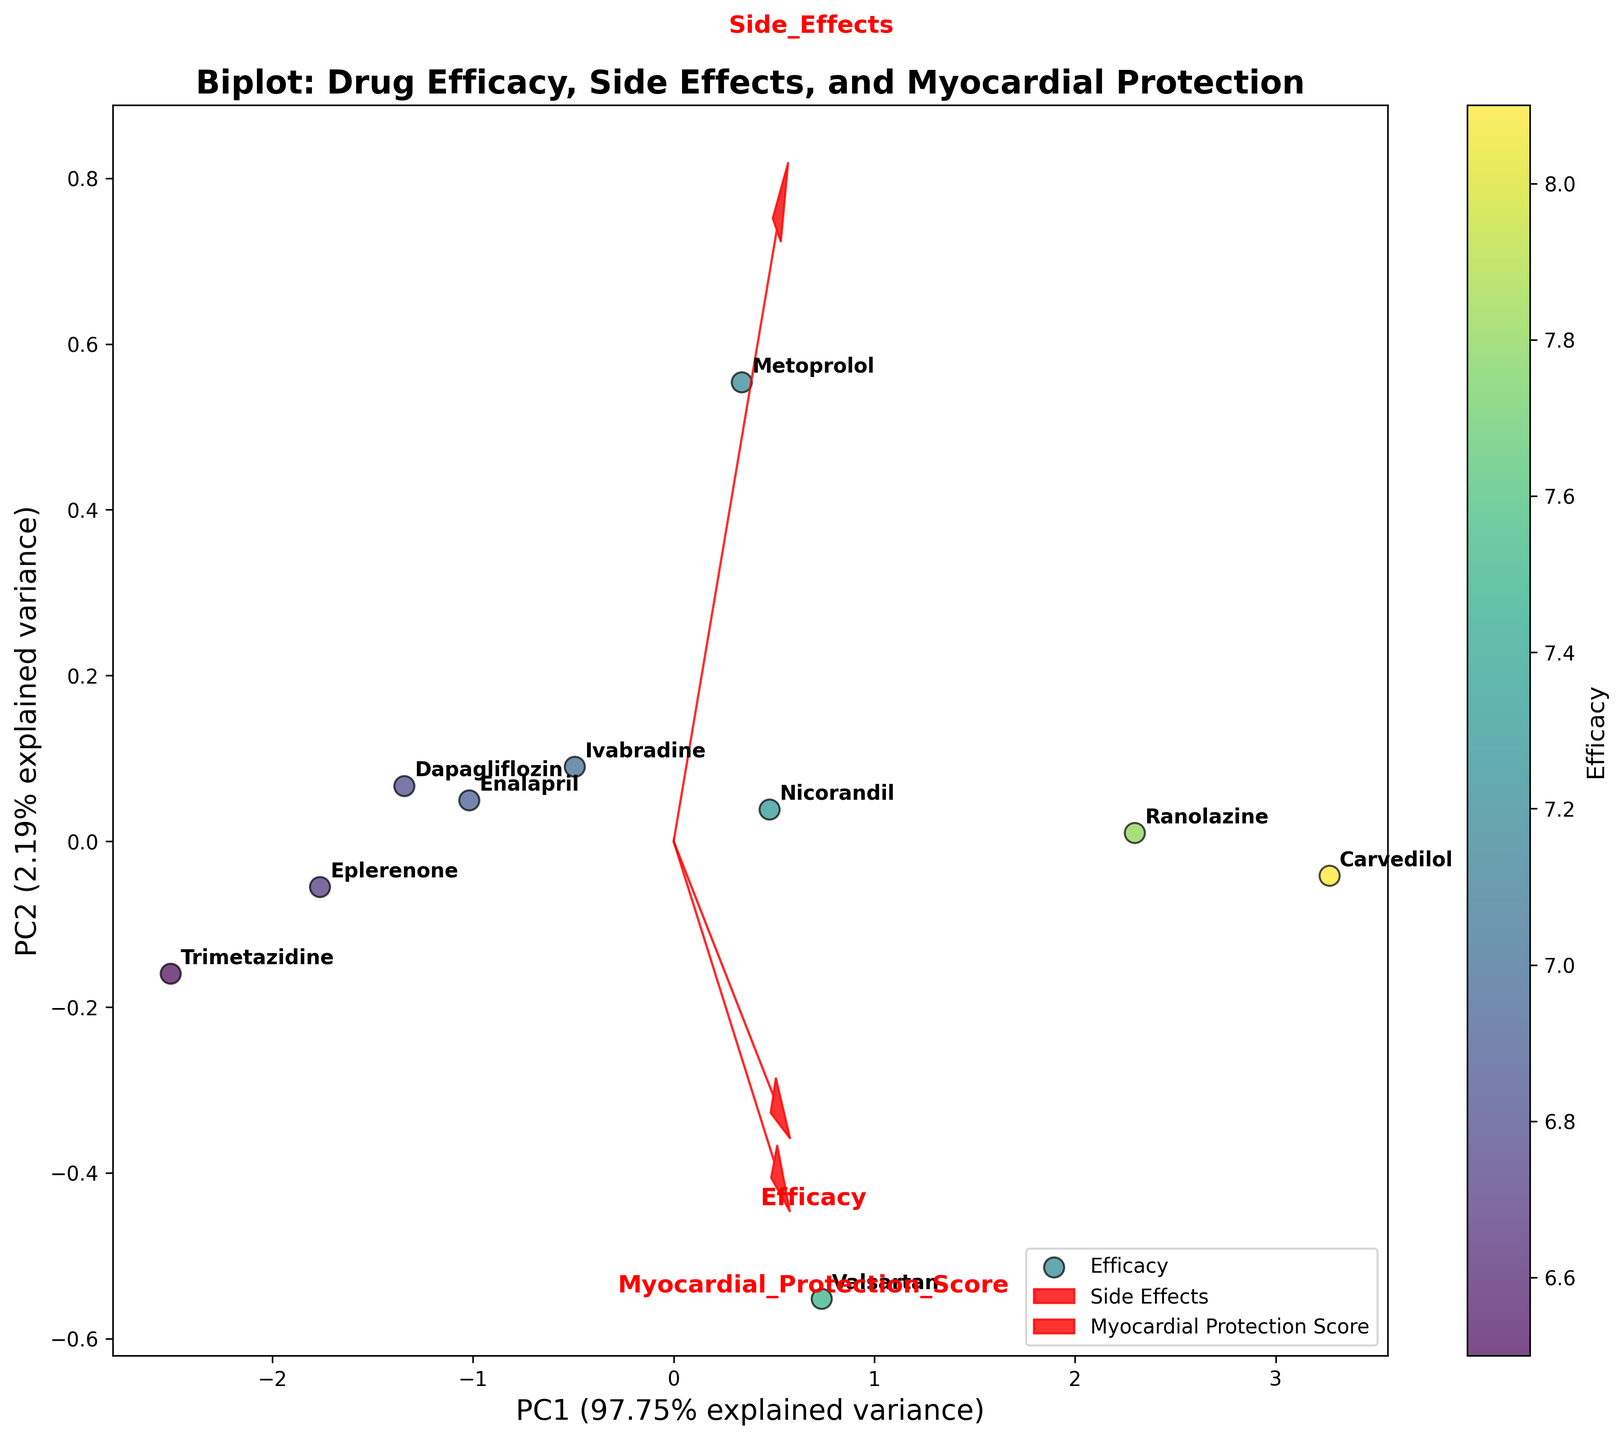What is the title of the figure? The title of the figure is displayed at the top of the plot. It summarizes the content and purpose of the plot.
Answer: Biplot: Drug Efficacy, Side Effects, and Myocardial Protection Which drug shows the highest efficacy based on the color of the points? The color bar indicates that drugs with higher efficacy are shaded towards the warmer (yellow) end of the color spectrum. By looking at the point colors, the highest efficacy can be identified.
Answer: Carvedilol Which Principal Component (PC) explains the most variance in the data? The labels on the axes show the explained variance for each PC. The PC with the larger percentage denotes more variance explained.
Answer: PC1 Which drug has the lowest myocardial protection score and where is it located on the plot? The annotations label the drugs, and we can identify the drug with the lowest myocardial protection score by locating the corresponding point on the plot.
Answer: Trimetazidine How much more variance does PC1 explain compared to PC2? The axes indicate the percentage of variance explained by each PC. Subtract the percentage of variance explained by PC2 from that explained by PC1 to find the difference.
Answer: 8.45% Which drugs are closer to the feature vector for Myocardial Protection Score? The feature vectors are represented by arrows. Drugs closer to the arrow labeled "Myocardial Protection Score" are influenced more by this variable.
Answer: Carvedilol and Ranolazine Is the drug with the lowest side effects closely aligned with the efficacy vector? Locate the drug with the lowest side effects based on the feature vector, then check its position relative to the efficacy vector.
Answer: No, Eplerenone (lowest side effects) is not closely aligned with the efficacy vector Which two drugs have the most similar profiles based on their positions in the plot? Closely located drugs in the plot indicate similar profiles. Identify the two drugs that are nearest to each other.
Answer: Metoprolol and Nicorandil Which variable has the least impact according to the length of the feature vectors? The length of each feature vector represents the impact of that variable. Identify the shortest arrow among efficacy, side effects, and myocardial protection score.
Answer: Side Effects Are there any drugs with a high efficacy but also high side effects? High efficacy is indicated by a hotter color. High side effects should align closer to the side effects vector. Identify any such drugs.
Answer: Ranolazine and Carvedilol 